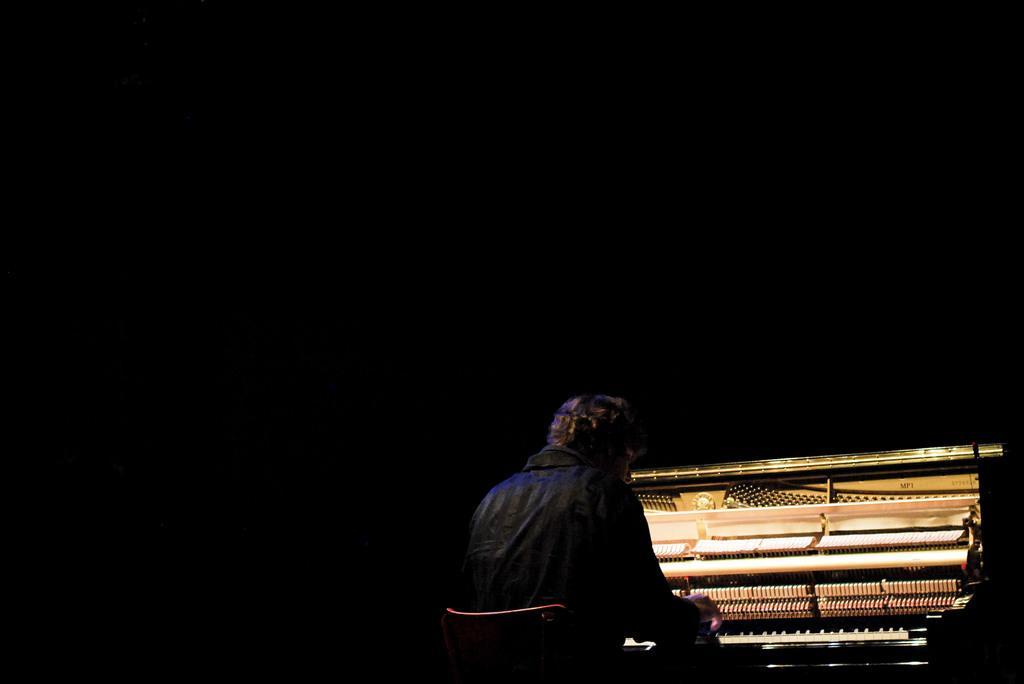In one or two sentences, can you explain what this image depicts? In this image there is a man sitting in the chair and playing a piano. 